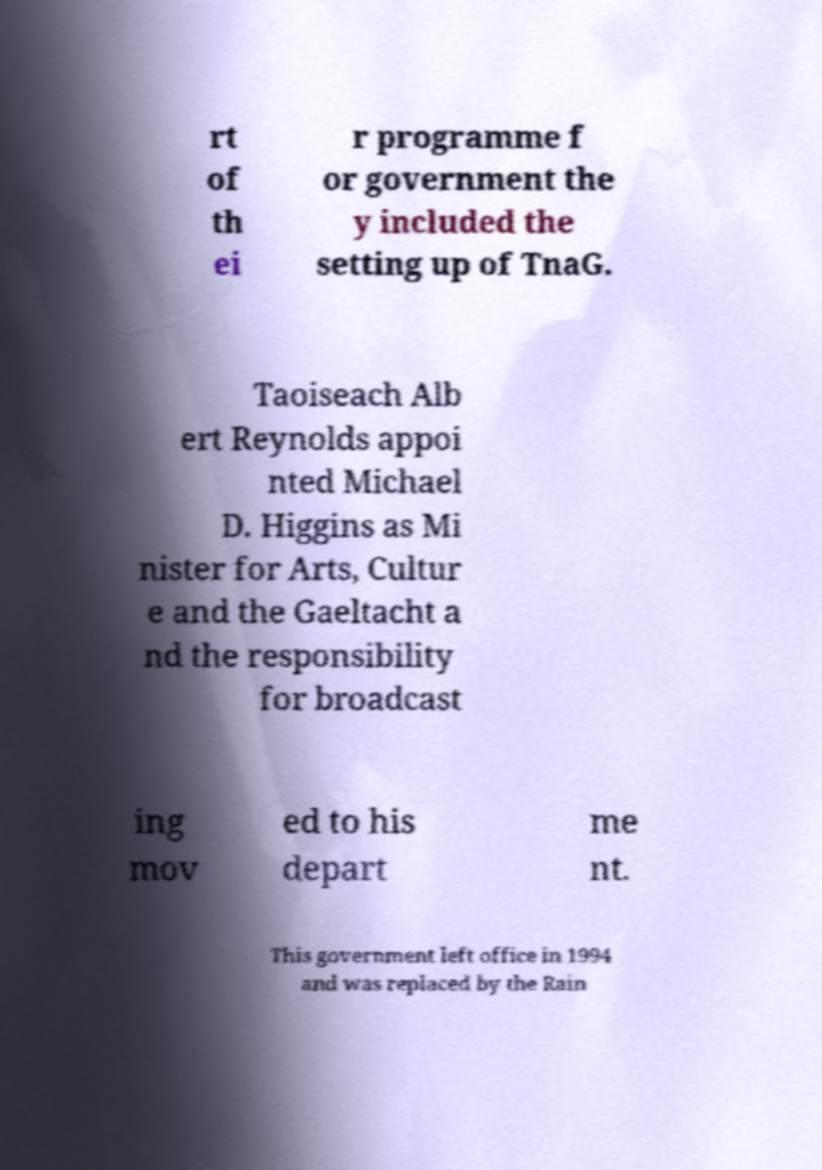Please read and relay the text visible in this image. What does it say? rt of th ei r programme f or government the y included the setting up of TnaG. Taoiseach Alb ert Reynolds appoi nted Michael D. Higgins as Mi nister for Arts, Cultur e and the Gaeltacht a nd the responsibility for broadcast ing mov ed to his depart me nt. This government left office in 1994 and was replaced by the Rain 